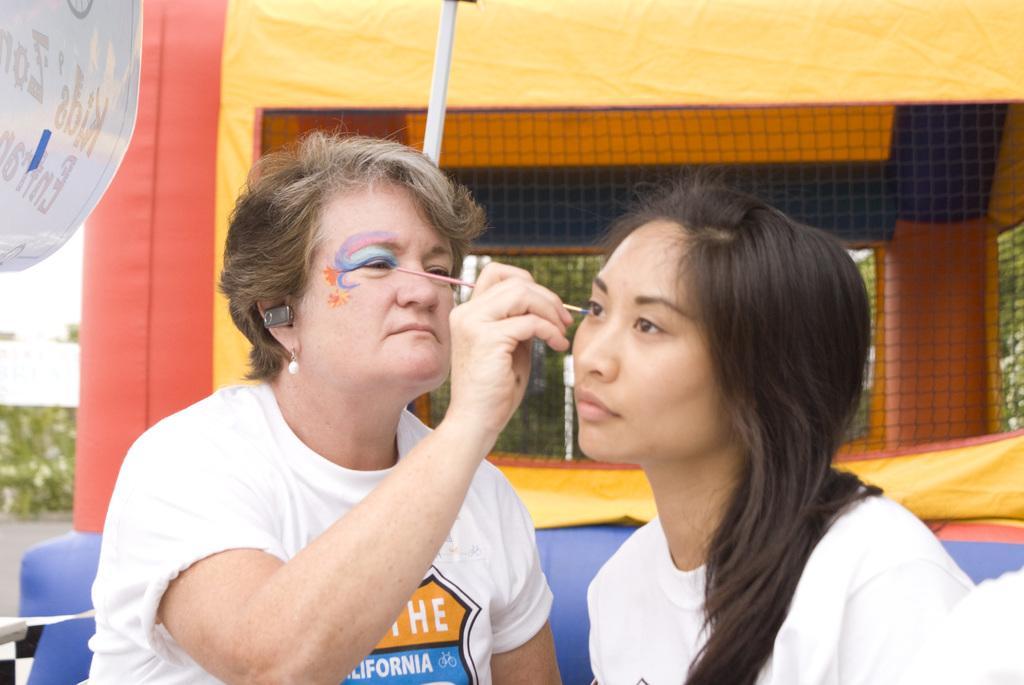In one or two sentences, can you explain what this image depicts? In this picture there is a woman holding a brush and painting on another woman face and we can see rod, banner, mesh and tent. In the background of the image we can see leaves. 